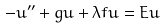Convert formula to latex. <formula><loc_0><loc_0><loc_500><loc_500>- u ^ { \prime \prime } + g u + \lambda f u = E u</formula> 